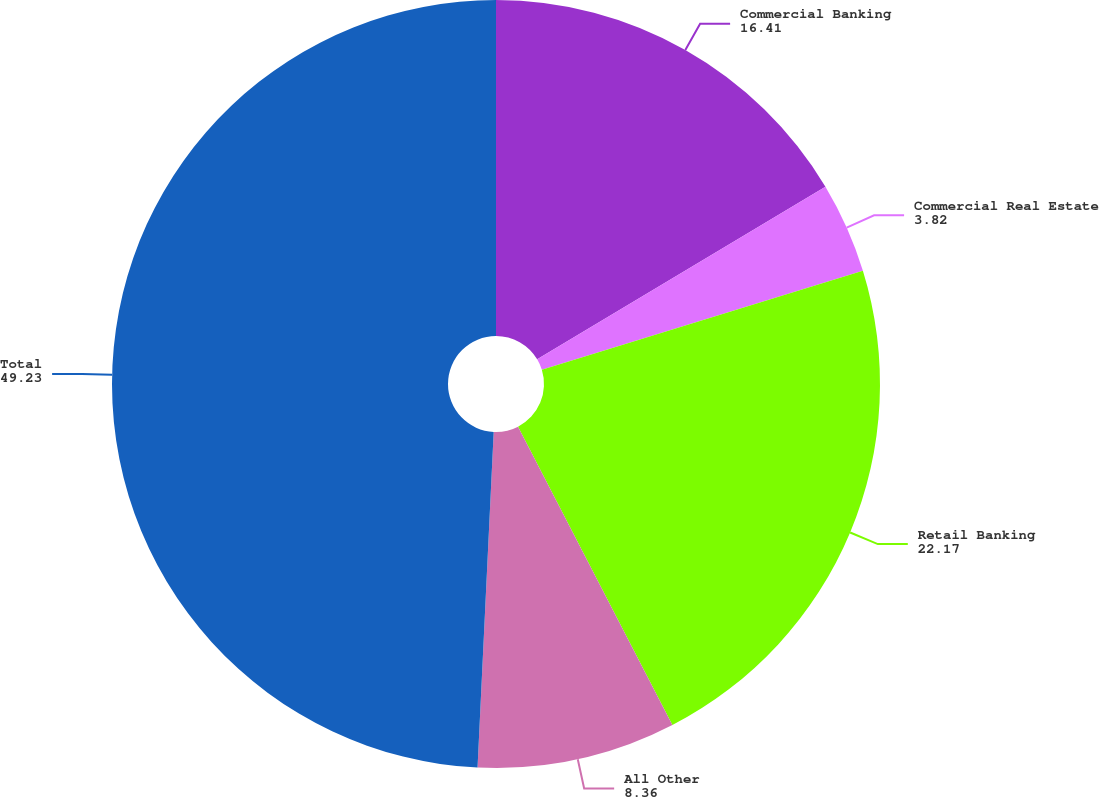<chart> <loc_0><loc_0><loc_500><loc_500><pie_chart><fcel>Commercial Banking<fcel>Commercial Real Estate<fcel>Retail Banking<fcel>All Other<fcel>Total<nl><fcel>16.41%<fcel>3.82%<fcel>22.17%<fcel>8.36%<fcel>49.23%<nl></chart> 